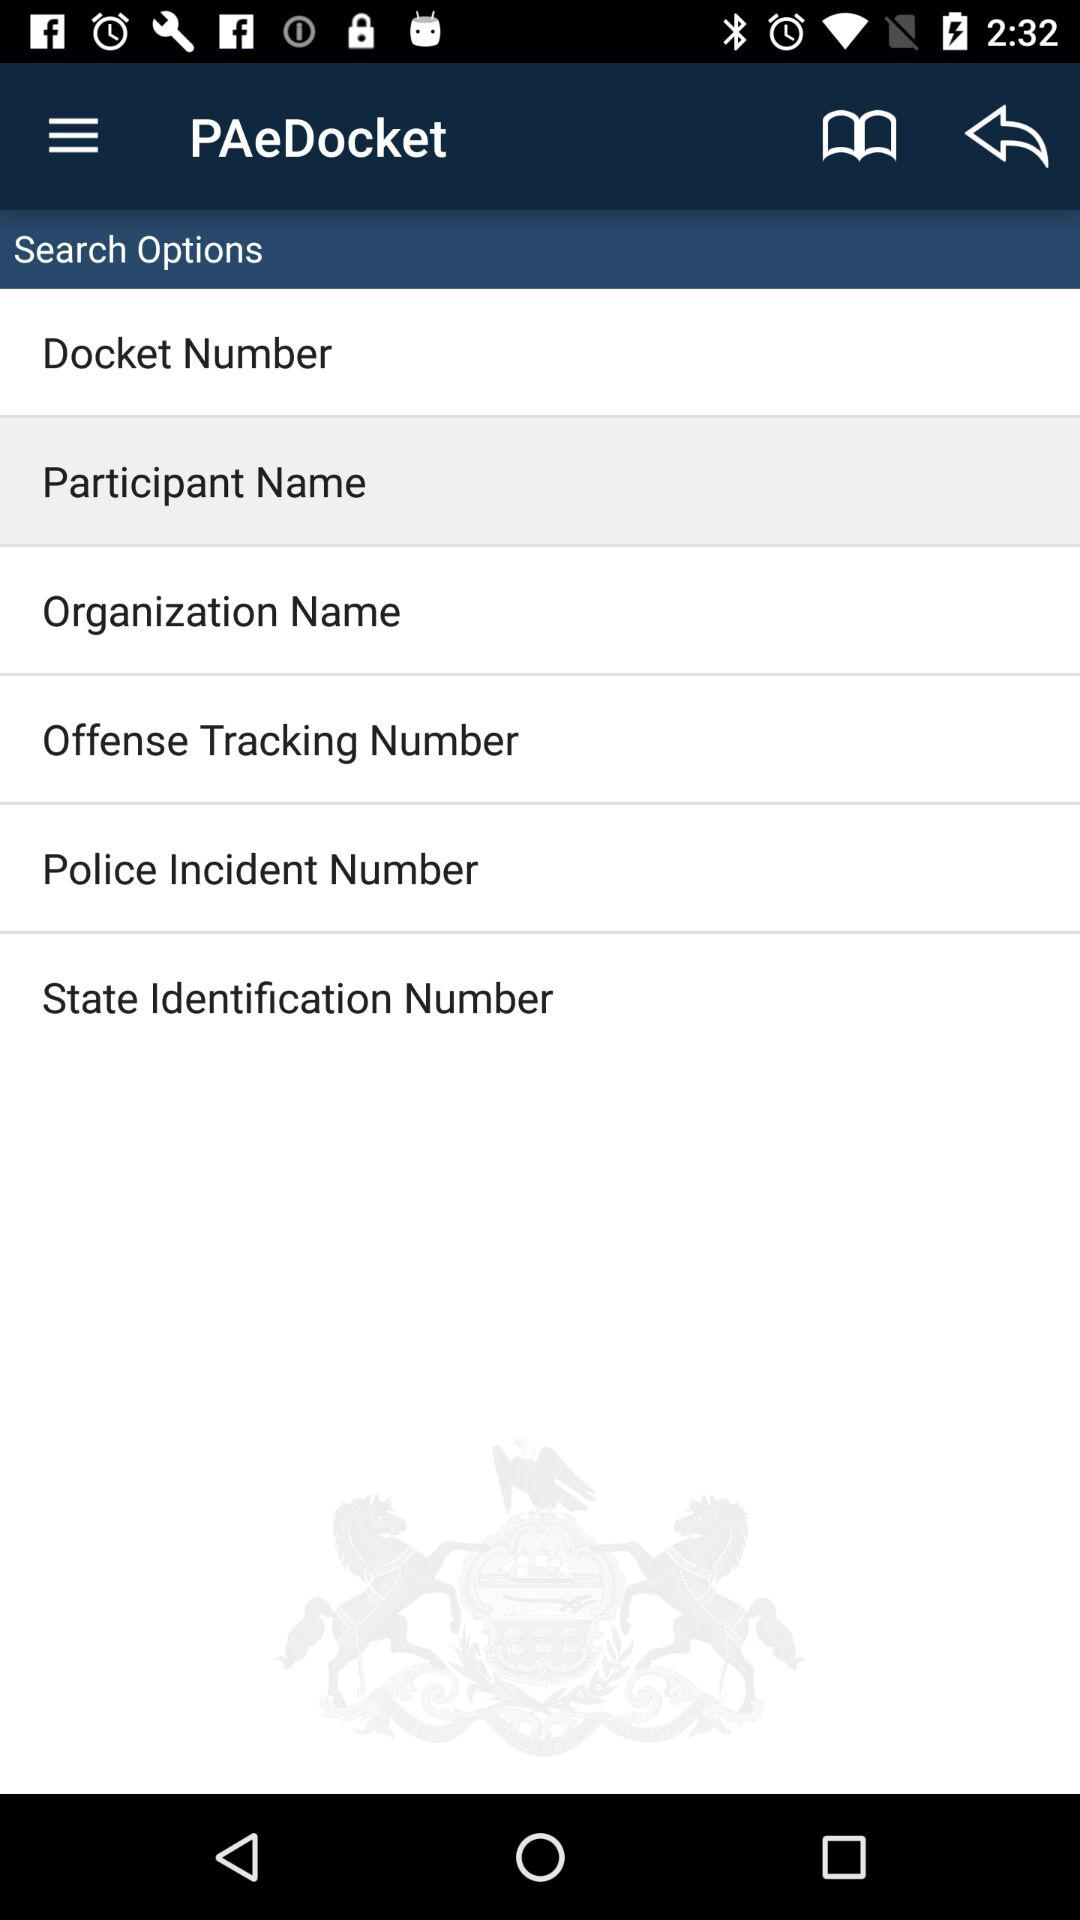What is the name of the application? The name of the application is "PAeDocket". 